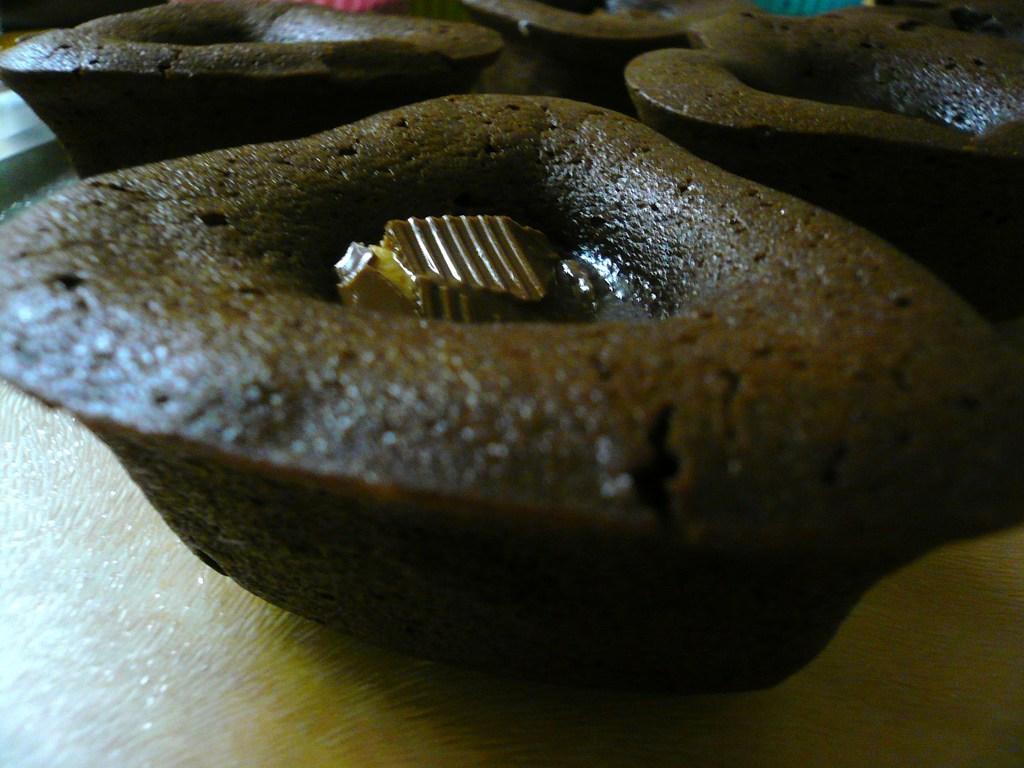Can you describe this image briefly? In this image, we can see some eatable things are placed on the surface. 